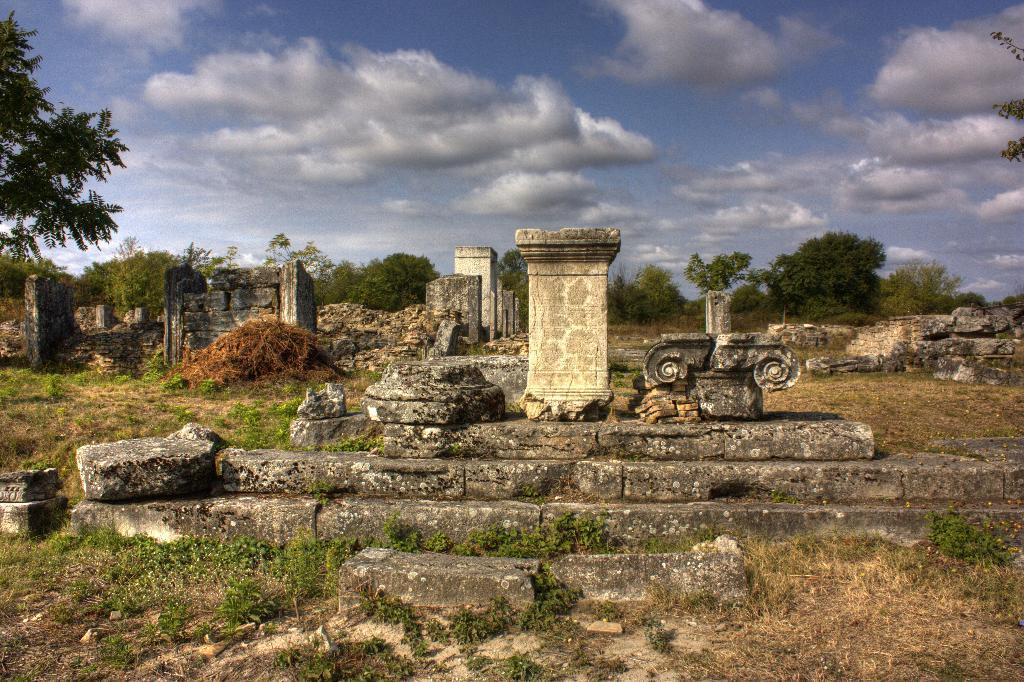Could you give a brief overview of what you see in this image? In this image, we can see trees, pillars, stairs, rocks, plants, grass and twigs. Background there is a cloudy sky. 